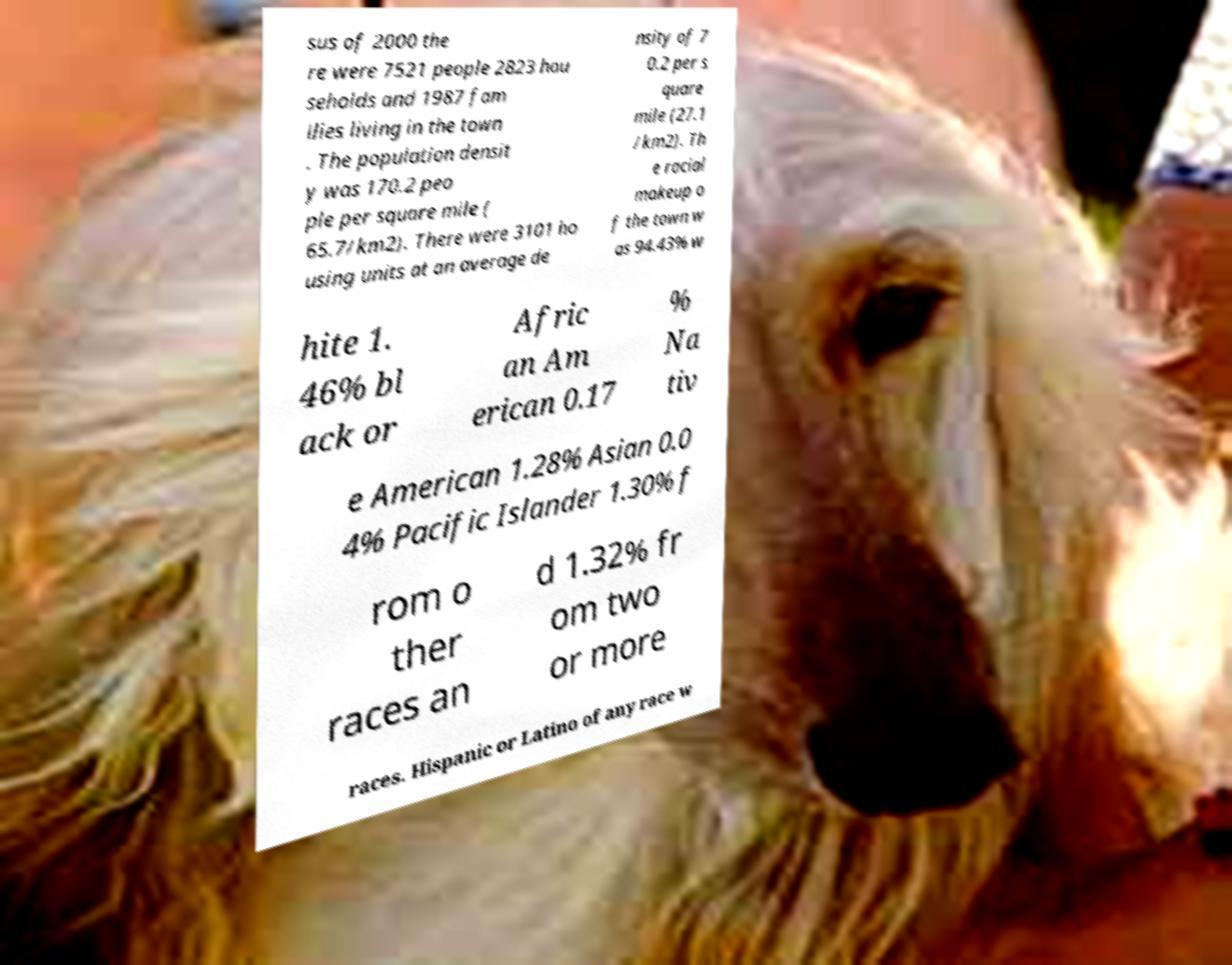Please identify and transcribe the text found in this image. sus of 2000 the re were 7521 people 2823 hou seholds and 1987 fam ilies living in the town . The population densit y was 170.2 peo ple per square mile ( 65.7/km2). There were 3101 ho using units at an average de nsity of 7 0.2 per s quare mile (27.1 /km2). Th e racial makeup o f the town w as 94.43% w hite 1. 46% bl ack or Afric an Am erican 0.17 % Na tiv e American 1.28% Asian 0.0 4% Pacific Islander 1.30% f rom o ther races an d 1.32% fr om two or more races. Hispanic or Latino of any race w 